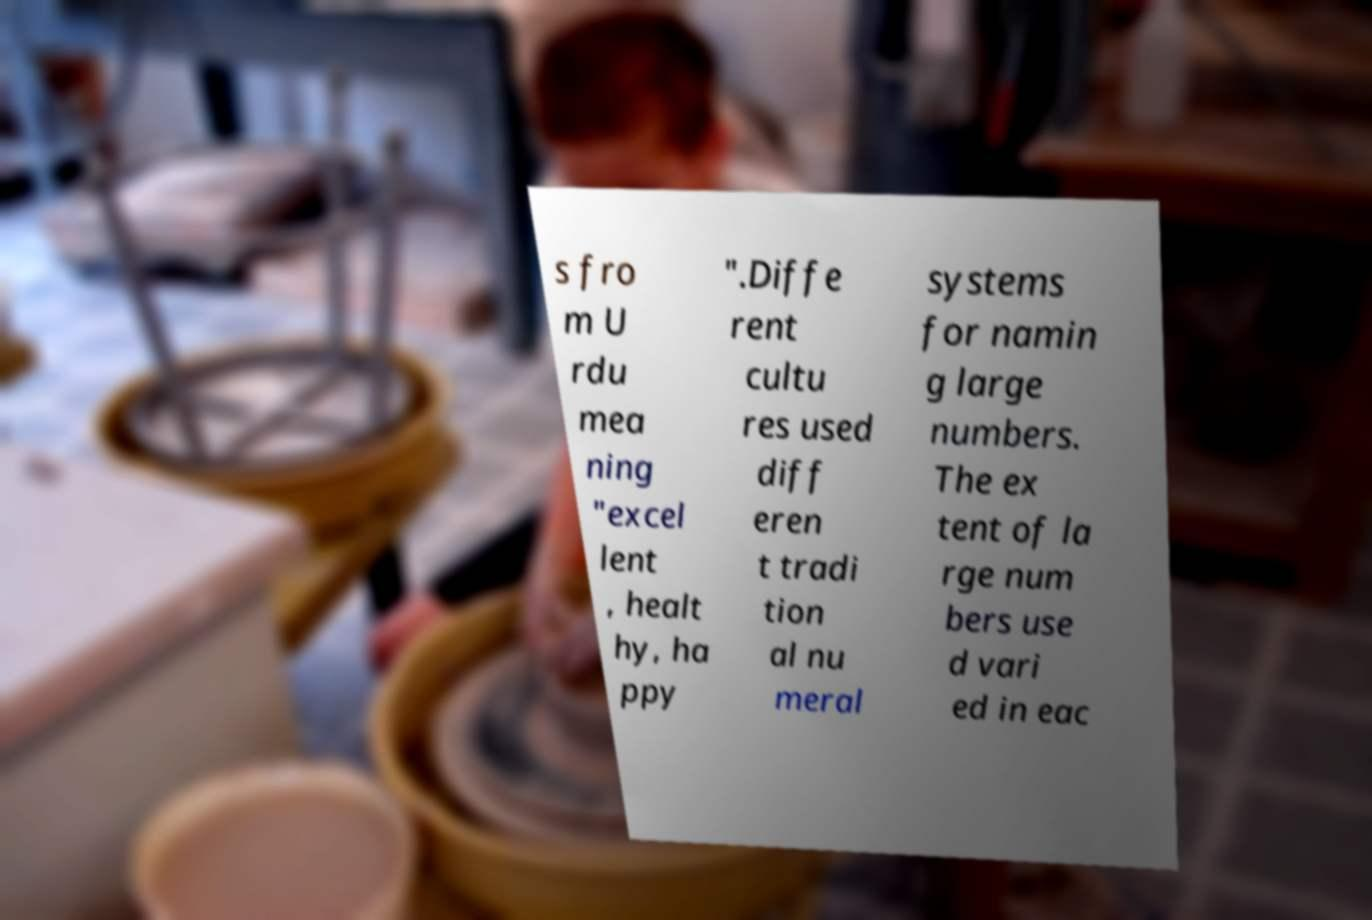I need the written content from this picture converted into text. Can you do that? s fro m U rdu mea ning "excel lent , healt hy, ha ppy ".Diffe rent cultu res used diff eren t tradi tion al nu meral systems for namin g large numbers. The ex tent of la rge num bers use d vari ed in eac 